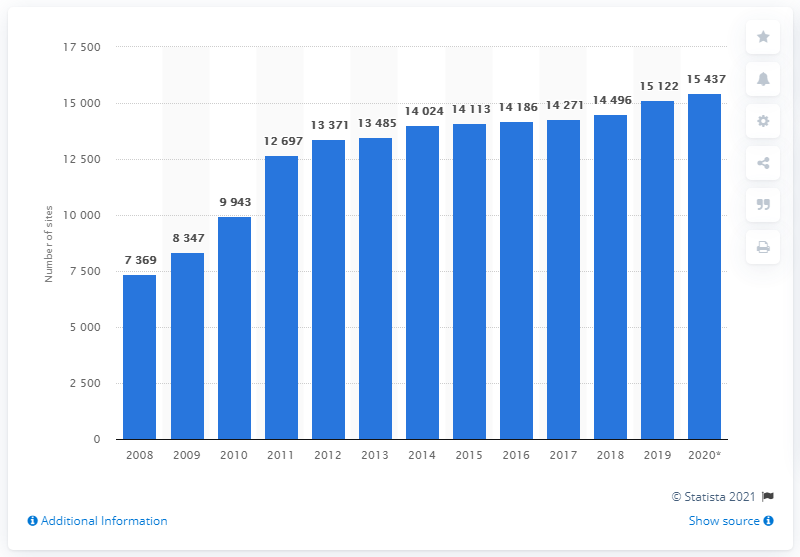Identify some key points in this picture. In 2012, the yearly increase in biomass power plants in Germany began to decrease. 